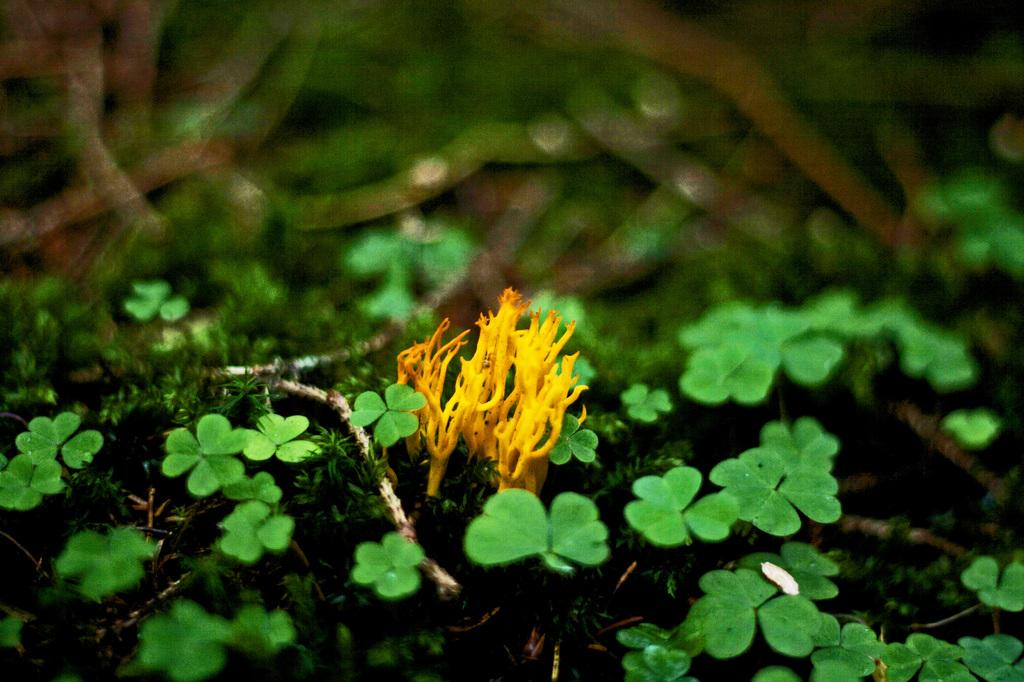What type of plants are in the image? There are baby plants in the image. Where are the baby plants located? The baby plants are in the soil. What type of attraction is the baby plants visiting in the image? There is no attraction present in the image; it features baby plants in the soil. What type of wool is being used to cover the baby plants in the image? There is no wool present in the image; it features baby plants in the soil. 